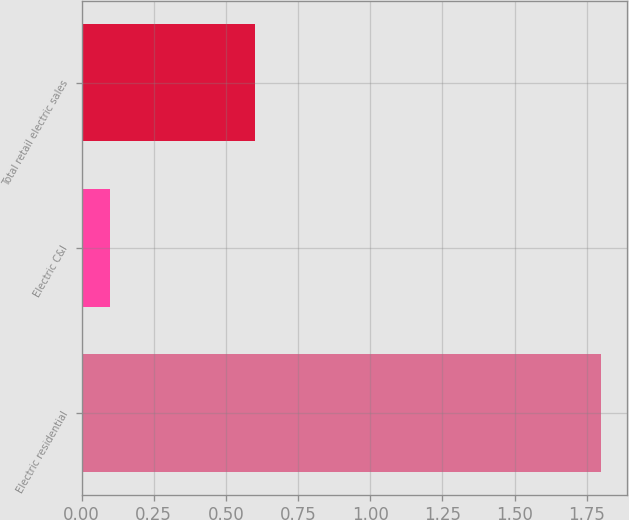Convert chart. <chart><loc_0><loc_0><loc_500><loc_500><bar_chart><fcel>Electric residential<fcel>Electric C&I<fcel>Total retail electric sales<nl><fcel>1.8<fcel>0.1<fcel>0.6<nl></chart> 